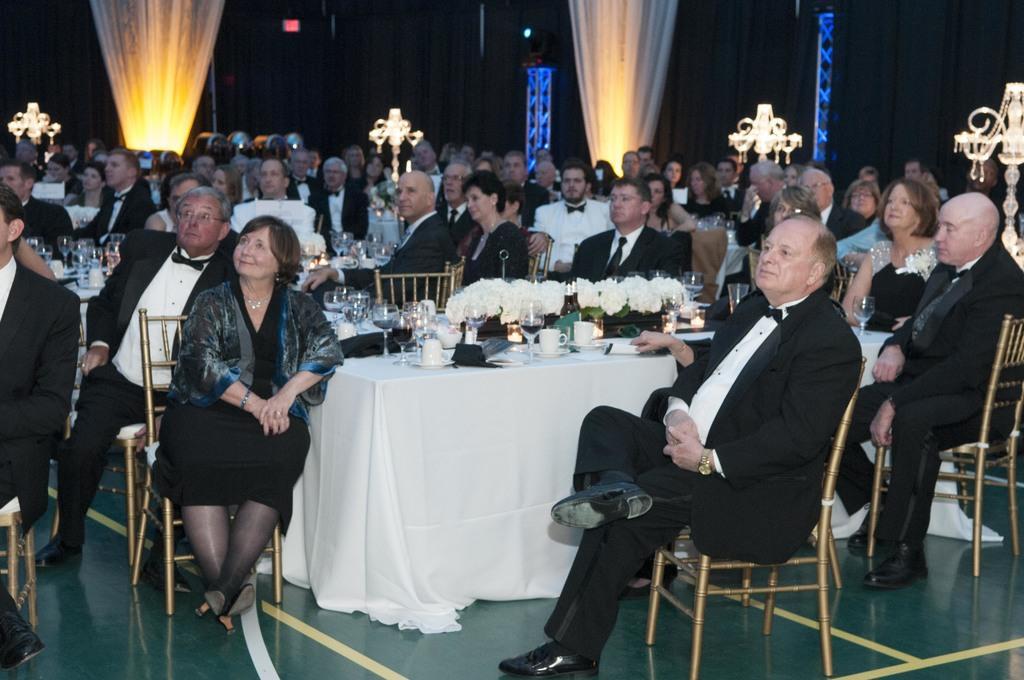Could you give a brief overview of what you see in this image? In this picture we can see group of people sitting on chair and in front of them there is table and on table we can see glasses, flowers, cups ,saucer, jackets and in background we can see curtains, steel rods. 